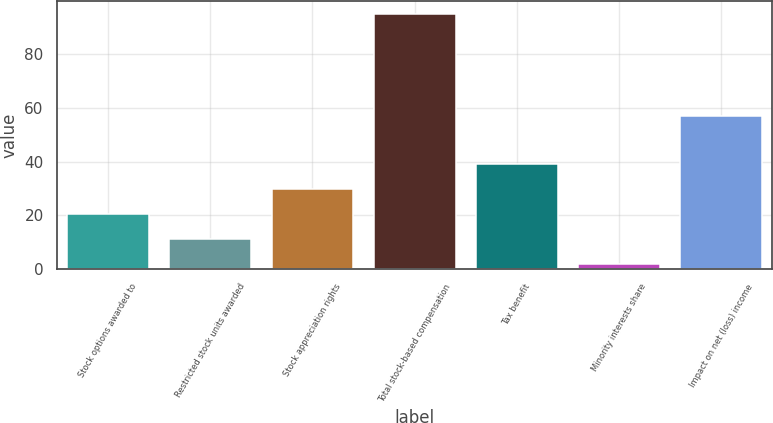Convert chart. <chart><loc_0><loc_0><loc_500><loc_500><bar_chart><fcel>Stock options awarded to<fcel>Restricted stock units awarded<fcel>Stock appreciation rights<fcel>Total stock-based compensation<fcel>Tax benefit<fcel>Minority interests share<fcel>Impact on net (loss) income<nl><fcel>20.6<fcel>11.3<fcel>29.9<fcel>95<fcel>39.2<fcel>2<fcel>57<nl></chart> 